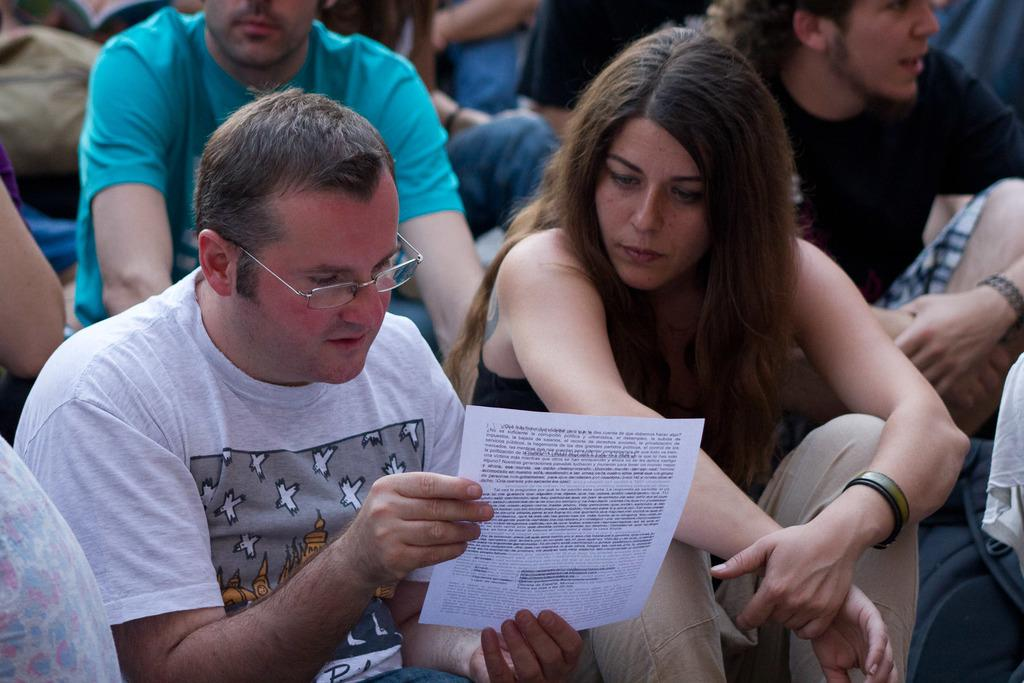What is the main subject of the image? There is a person sitting in the front of the image. What is the person in the front holding? The person is holding a paper in his hand. Can you describe the people in the background of the image? There are other persons sitting in the background of the image. What type of rhythm can be heard from the fairies in the image? There are no fairies present in the image, so it is not possible to determine any rhythm associated with them. 